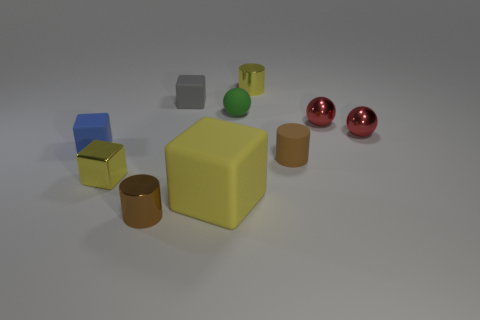How many metallic cylinders are the same color as the matte cylinder?
Make the answer very short. 1. What is the material of the object that is the same color as the small rubber cylinder?
Your answer should be compact. Metal. There is a tiny cylinder to the left of the small gray matte block; what color is it?
Provide a short and direct response. Brown. The gray thing has what shape?
Give a very brief answer. Cube. What is the material of the small brown object on the left side of the tiny yellow metallic object to the right of the small green thing?
Offer a very short reply. Metal. How many other objects are the same material as the blue cube?
Provide a succinct answer. 4. What material is the brown thing that is the same size as the matte cylinder?
Give a very brief answer. Metal. Are there more tiny brown objects that are right of the yellow metal cylinder than blocks that are behind the tiny gray block?
Offer a terse response. Yes. Are there any red metallic objects that have the same shape as the blue object?
Provide a short and direct response. No. What shape is the blue matte object that is the same size as the brown matte thing?
Make the answer very short. Cube. 